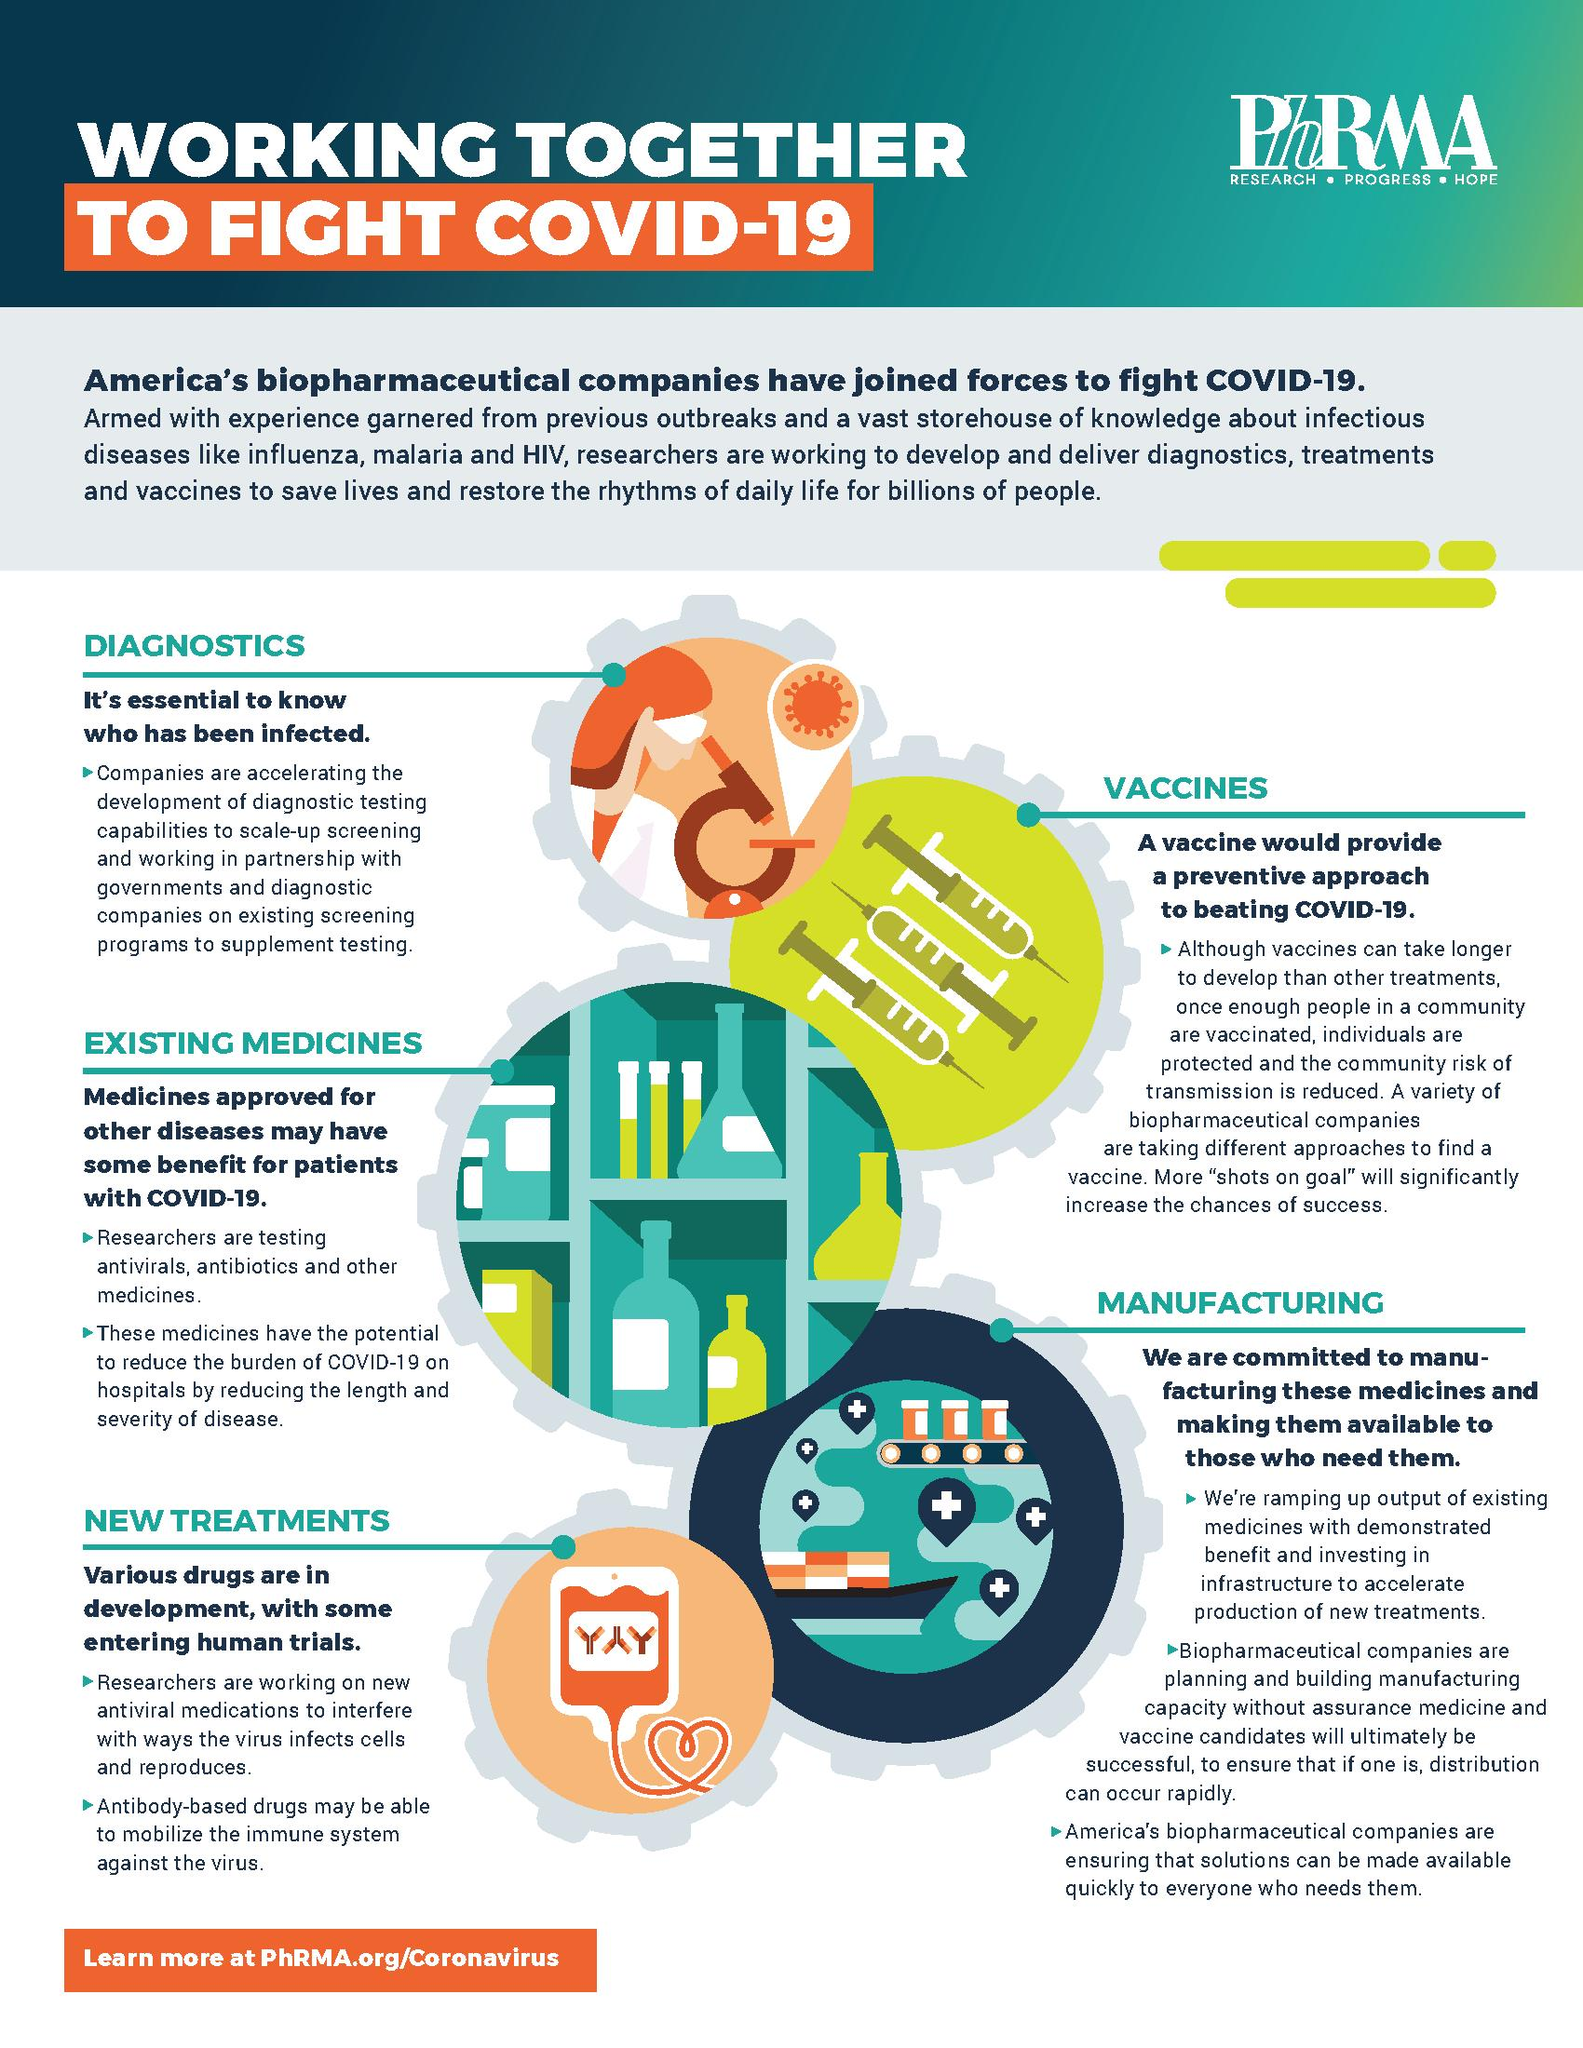Outline some significant characteristics in this image. There are two points under the heading "New Treatments. There are a total of three points under the heading "Manufacturing. There are two points under the heading "Existing Medicines". There is one point under the heading "Diagnostics". There is exactly one point under the heading "Vaccines". 